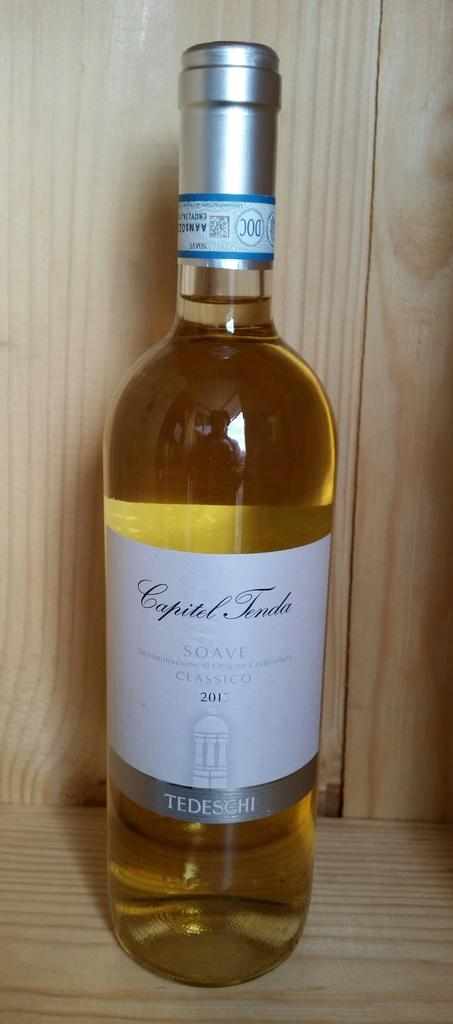What is the main object in the image? There is a wine bottle in the image. What is the color of the cap on the wine bottle? The cap on the wine bottle has a silver color. Is there any label or sticker on the cap? Yes, there is a white color sticker on the cap. What type of background can be seen in the image? There is a wooden background in the image. What type of breakfast is being served on the wooden background in the image? There is no breakfast or food visible in the image; it only features a wine bottle with a silver cap and a white sticker. 